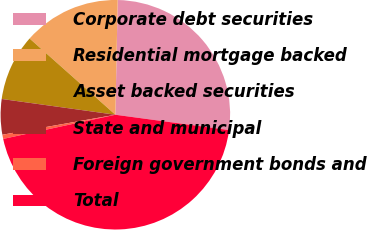Convert chart. <chart><loc_0><loc_0><loc_500><loc_500><pie_chart><fcel>Corporate debt securities<fcel>Residential mortgage backed<fcel>Asset backed securities<fcel>State and municipal<fcel>Foreign government bonds and<fcel>Total<nl><fcel>26.81%<fcel>13.76%<fcel>9.37%<fcel>4.98%<fcel>0.59%<fcel>44.49%<nl></chart> 